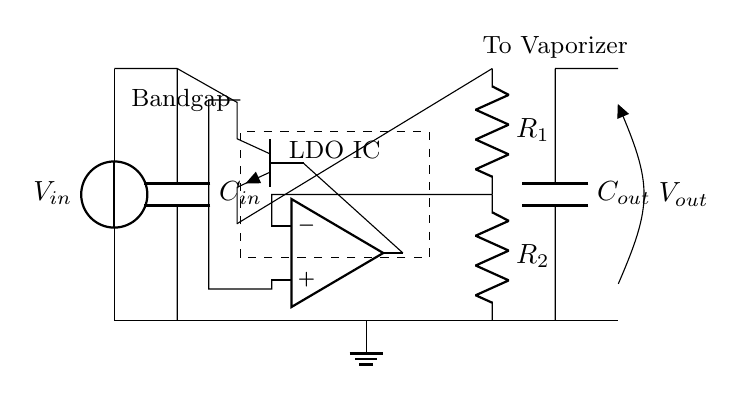What is the type of capacitor at the input? The capacitor at the input is labeled as C_in, indicating a capacitor used for filtering the input voltage.
Answer: Input capacitor What is the output voltage of this circuit? The output voltage is represented as V_out in the diagram, which delivers the regulated voltage to the vaporizer.
Answer: V_out What does the dashed rectangle represent in the circuit? The dashed rectangle encloses the LDO integrated circuit (IC), which is responsible for regulating the output voltage.
Answer: LDO IC How many resistors are in the feedback network? There are two resistors labeled R_1 and R_2 that form the feedback loop for the error amplifier in the LDO circuit.
Answer: Two What role does the error amplifier play in this circuit? The error amplifier compares the output voltage against a reference voltage and adjusts the pass transistor accordingly to maintain regulation.
Answer: Regulation Which components are responsible for smoothing the output voltage? The output capacitor labeled C_out is responsible for smoothing out the regulated output voltage by filtering any fluctuations.
Answer: Output capacitor What type of transistor is used in this regulator circuit? The transistor used is an NPN transistor, indicated by the npn notation next to the symbol in the diagram, which acts as the pass element in the regulation process.
Answer: NPN transistor 